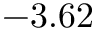<formula> <loc_0><loc_0><loc_500><loc_500>- 3 . 6 2</formula> 